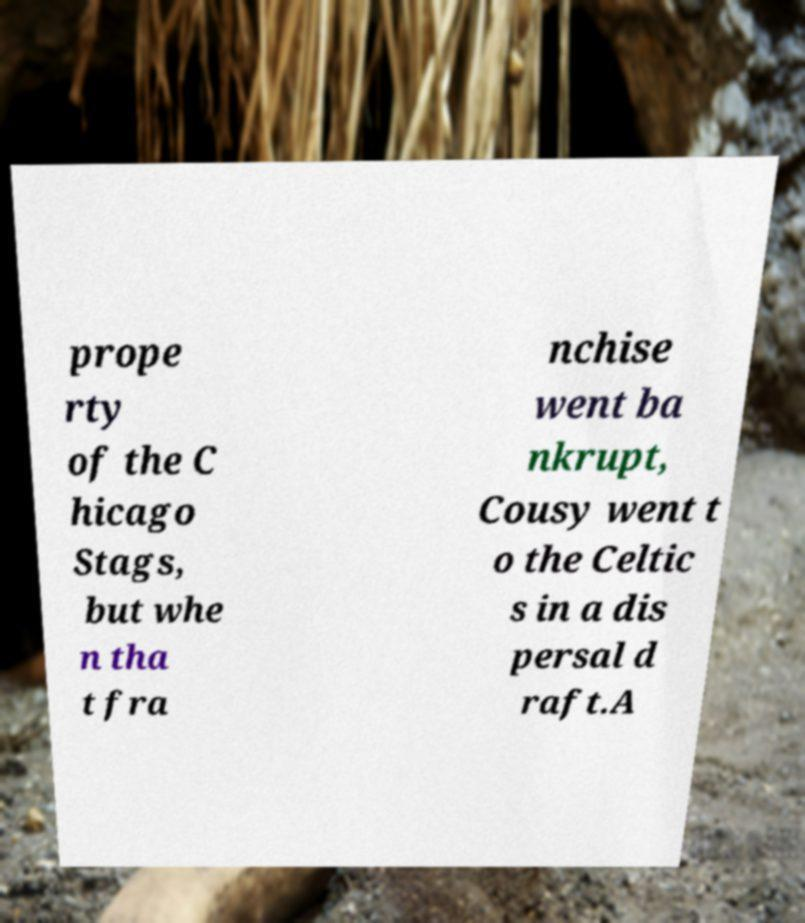There's text embedded in this image that I need extracted. Can you transcribe it verbatim? prope rty of the C hicago Stags, but whe n tha t fra nchise went ba nkrupt, Cousy went t o the Celtic s in a dis persal d raft.A 